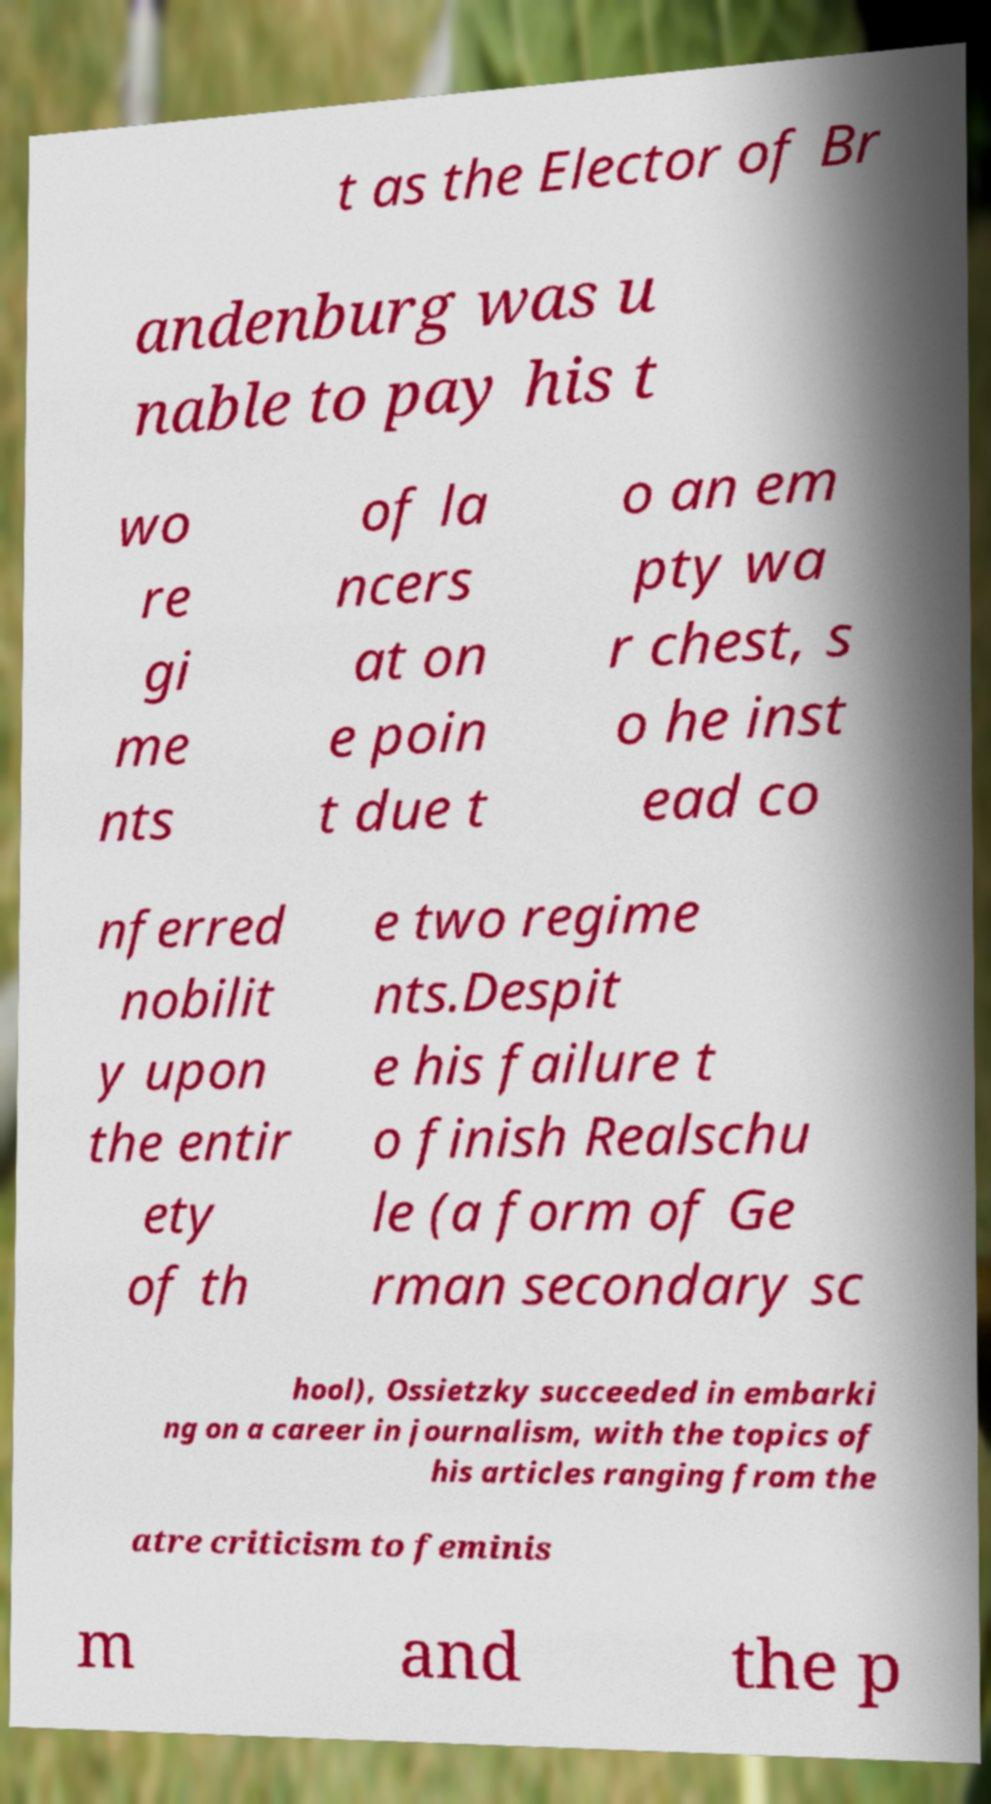Please identify and transcribe the text found in this image. t as the Elector of Br andenburg was u nable to pay his t wo re gi me nts of la ncers at on e poin t due t o an em pty wa r chest, s o he inst ead co nferred nobilit y upon the entir ety of th e two regime nts.Despit e his failure t o finish Realschu le (a form of Ge rman secondary sc hool), Ossietzky succeeded in embarki ng on a career in journalism, with the topics of his articles ranging from the atre criticism to feminis m and the p 